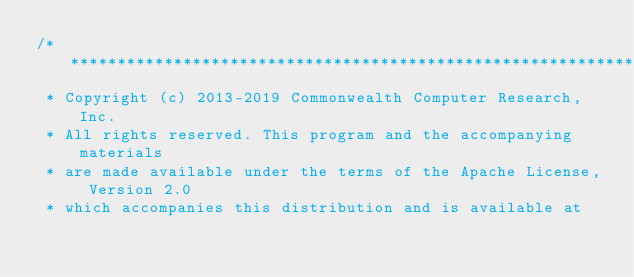Convert code to text. <code><loc_0><loc_0><loc_500><loc_500><_Scala_>/***********************************************************************
 * Copyright (c) 2013-2019 Commonwealth Computer Research, Inc.
 * All rights reserved. This program and the accompanying materials
 * are made available under the terms of the Apache License, Version 2.0
 * which accompanies this distribution and is available at</code> 